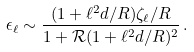<formula> <loc_0><loc_0><loc_500><loc_500>\epsilon _ { \ell } \sim \frac { ( 1 + \ell ^ { 2 } d / R ) \zeta _ { \ell } / R } { 1 + { \mathcal { R } } ( 1 + \ell ^ { 2 } d / R ) ^ { 2 } } \, .</formula> 